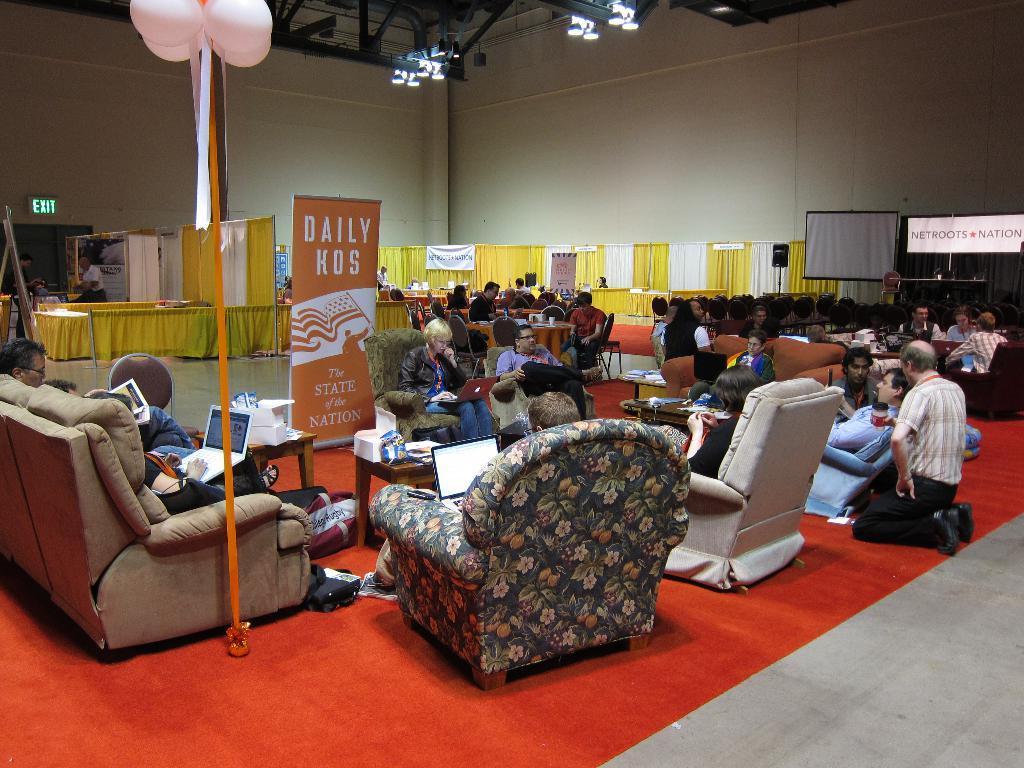Please provide a concise description of this image. there are so many people sitting in sofas in a hall behind them there is a stalls, screen, banner and a balloons on pole and lights. 